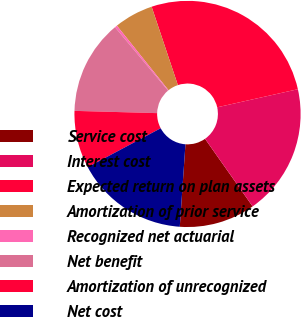Convert chart. <chart><loc_0><loc_0><loc_500><loc_500><pie_chart><fcel>Service cost<fcel>Interest cost<fcel>Expected return on plan assets<fcel>Amortization of prior service<fcel>Recognized net actuarial<fcel>Net benefit<fcel>Amortization of unrecognized<fcel>Net cost<nl><fcel>10.86%<fcel>18.75%<fcel>26.64%<fcel>5.6%<fcel>0.34%<fcel>13.49%<fcel>8.23%<fcel>16.12%<nl></chart> 